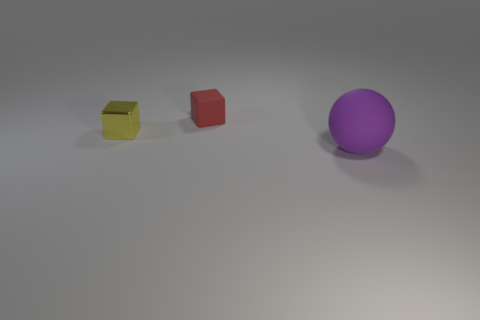Is there any other thing that is the same shape as the purple object?
Keep it short and to the point. No. There is a rubber thing that is to the left of the purple object; is it the same size as the big rubber object?
Ensure brevity in your answer.  No. How big is the matte object that is on the left side of the sphere that is in front of the yellow metal thing?
Provide a short and direct response. Small. Does the tiny red cube have the same material as the tiny thing that is in front of the tiny red rubber object?
Offer a terse response. No. Are there fewer large purple balls that are in front of the ball than purple spheres that are in front of the small yellow cube?
Keep it short and to the point. Yes. There is a small block that is the same material as the large purple thing; what is its color?
Make the answer very short. Red. There is a block on the right side of the yellow metal block; is there a metal cube right of it?
Your answer should be compact. No. The cube that is the same size as the red rubber thing is what color?
Give a very brief answer. Yellow. What number of things are either cubes or big yellow matte balls?
Give a very brief answer. 2. What size is the thing that is on the left side of the rubber thing that is left of the matte thing that is to the right of the tiny rubber object?
Your answer should be very brief. Small. 